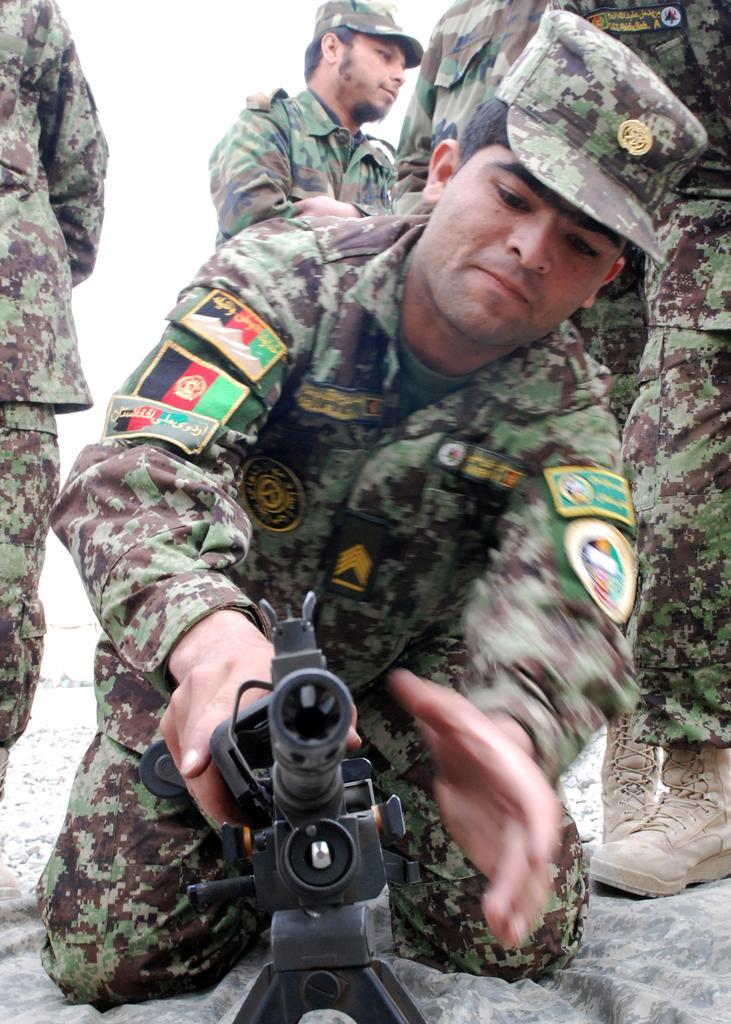Can you describe this image briefly? In this image we can see a person wearing uniform and cap is sitting and there is weapon here. In the background, we can see a few more people in uniforms. 